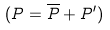<formula> <loc_0><loc_0><loc_500><loc_500>( P = \overline { P } + P ^ { \prime } )</formula> 